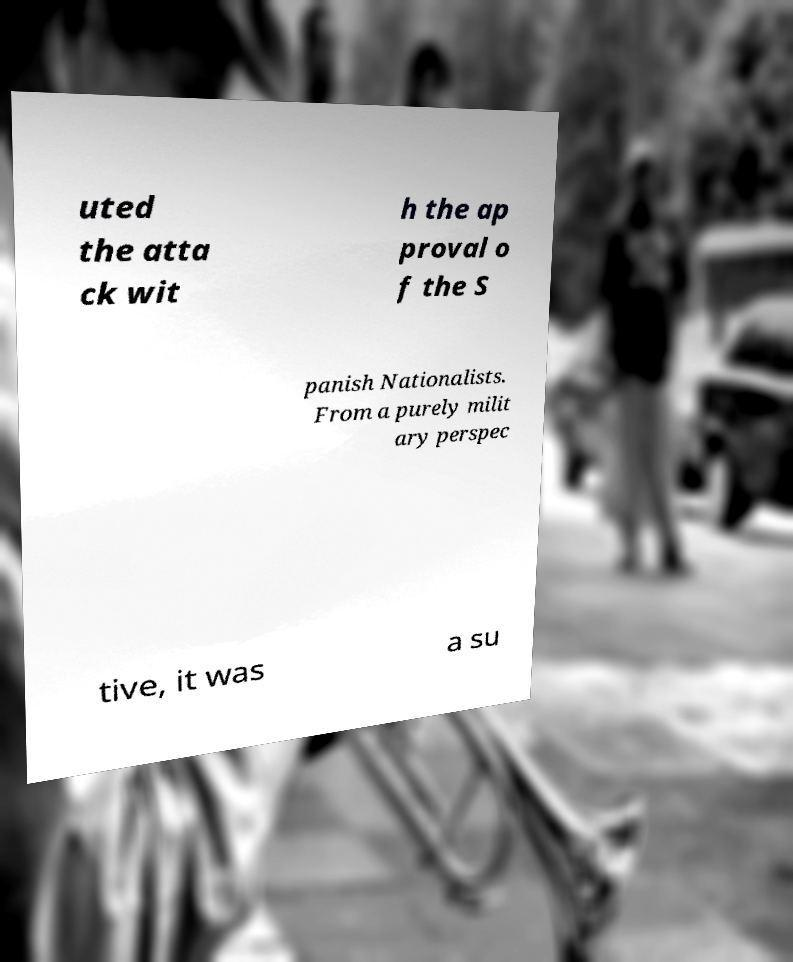For documentation purposes, I need the text within this image transcribed. Could you provide that? uted the atta ck wit h the ap proval o f the S panish Nationalists. From a purely milit ary perspec tive, it was a su 